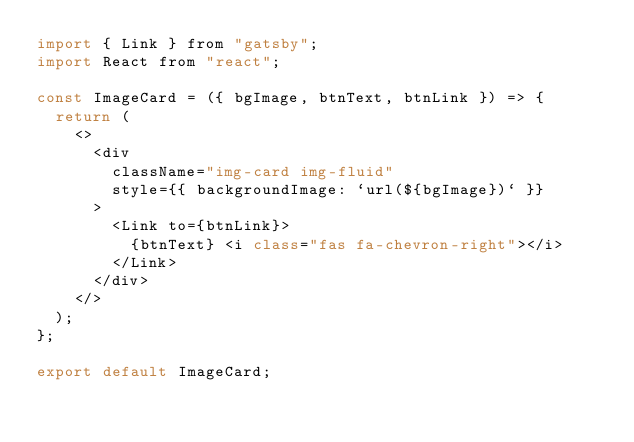<code> <loc_0><loc_0><loc_500><loc_500><_JavaScript_>import { Link } from "gatsby";
import React from "react";

const ImageCard = ({ bgImage, btnText, btnLink }) => {
  return (
    <>
      <div
        className="img-card img-fluid"
        style={{ backgroundImage: `url(${bgImage})` }}
      >
        <Link to={btnLink}>
          {btnText} <i class="fas fa-chevron-right"></i>
        </Link>
      </div>
    </>
  );
};

export default ImageCard;
</code> 